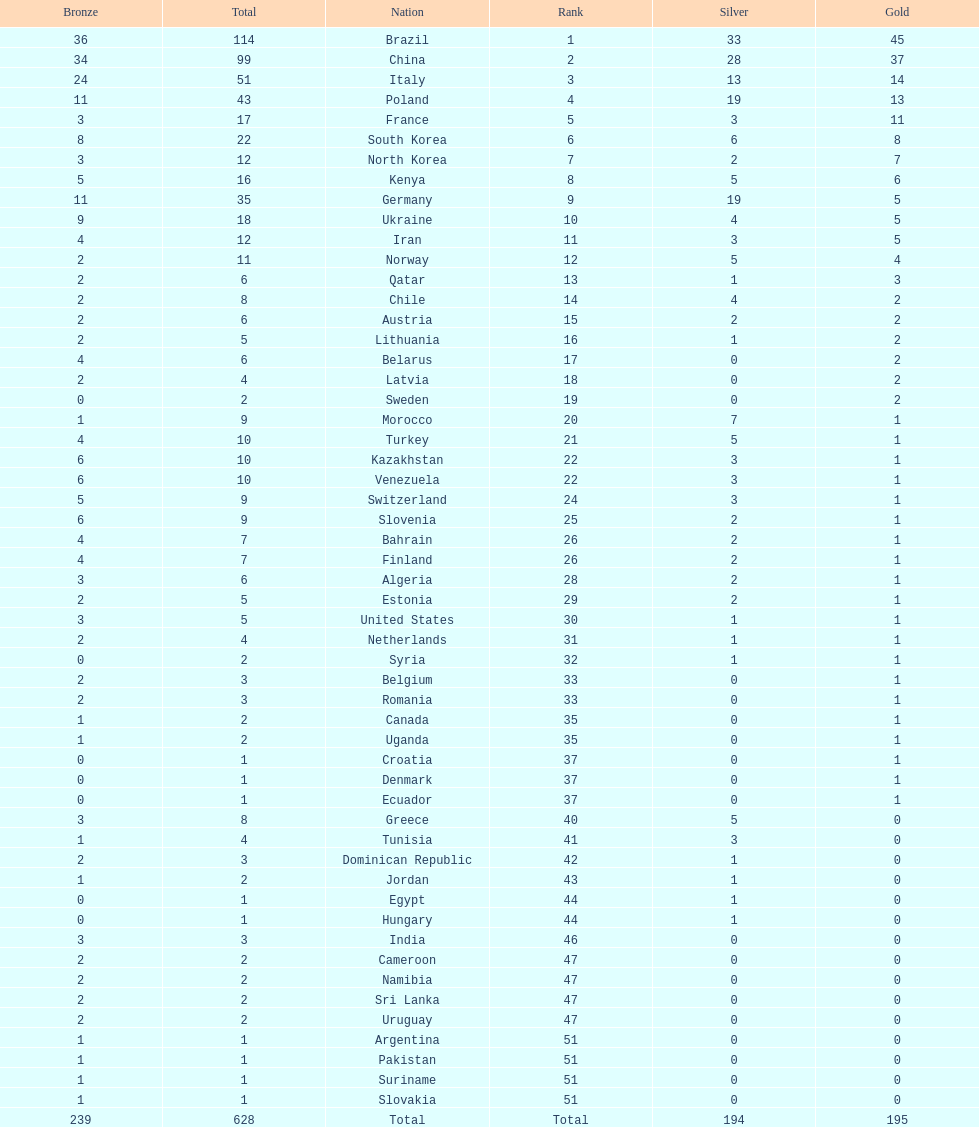South korea has how many more medals that north korea? 10. 